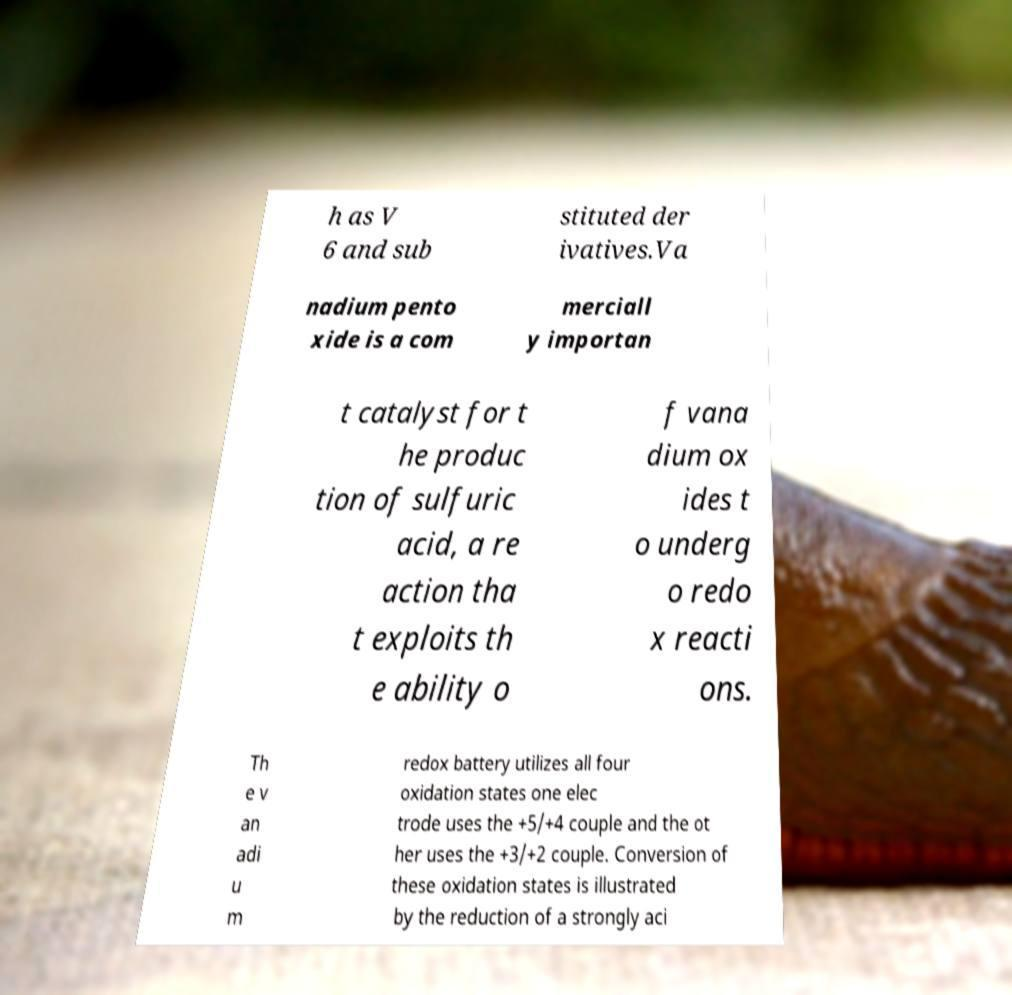Could you extract and type out the text from this image? h as V 6 and sub stituted der ivatives.Va nadium pento xide is a com merciall y importan t catalyst for t he produc tion of sulfuric acid, a re action tha t exploits th e ability o f vana dium ox ides t o underg o redo x reacti ons. Th e v an adi u m redox battery utilizes all four oxidation states one elec trode uses the +5/+4 couple and the ot her uses the +3/+2 couple. Conversion of these oxidation states is illustrated by the reduction of a strongly aci 